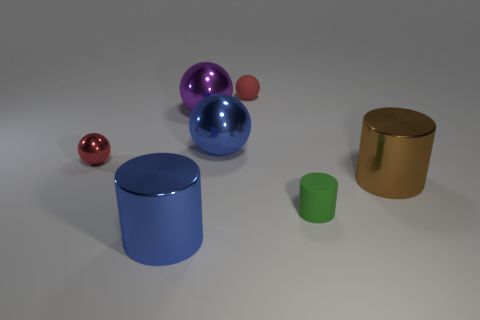Add 1 big rubber blocks. How many objects exist? 8 Subtract all red balls. How many balls are left? 2 Subtract all big blue shiny cylinders. How many cylinders are left? 2 Add 2 small things. How many small things are left? 5 Add 1 small gray metallic cubes. How many small gray metallic cubes exist? 1 Subtract 0 yellow cylinders. How many objects are left? 7 Subtract all balls. How many objects are left? 3 Subtract 1 cylinders. How many cylinders are left? 2 Subtract all cyan spheres. Subtract all purple cylinders. How many spheres are left? 4 Subtract all green cubes. How many red balls are left? 2 